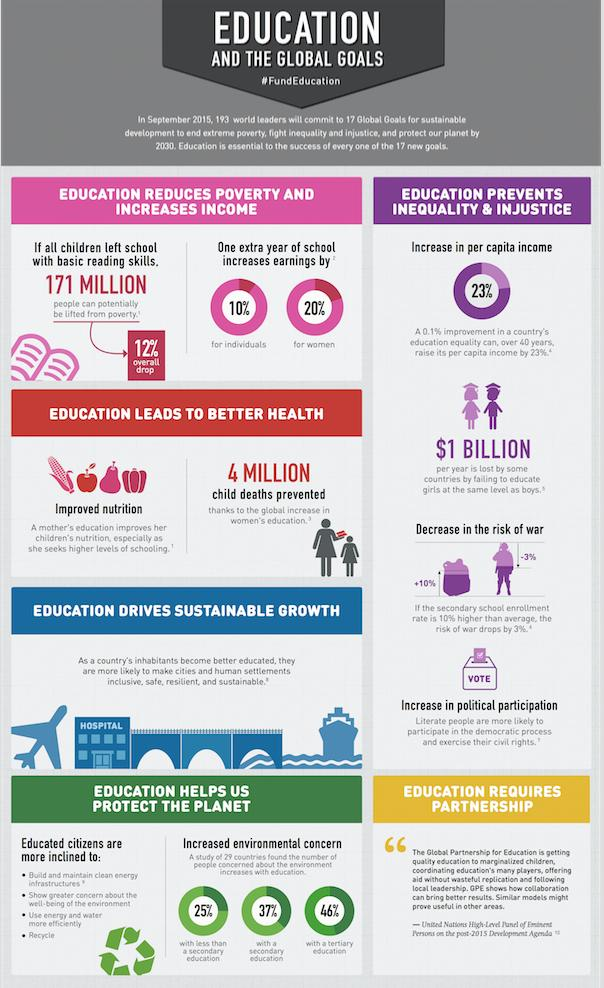Mention a couple of crucial points in this snapshot. Educated citizens are more likely to recycle and efficiently use water. The annual loss for countries that fail to educate girls as much as boys is estimated to be $1 billion. Increased access to education for women has been responsible for preventing 4 million child deaths. In the study, 46% of individuals with tertiary education showed increased environmental concern. According to the data, an increase of 20% in earnings can be expected for women who have obtained an additional year of education. 